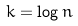Convert formula to latex. <formula><loc_0><loc_0><loc_500><loc_500>k = \log n</formula> 